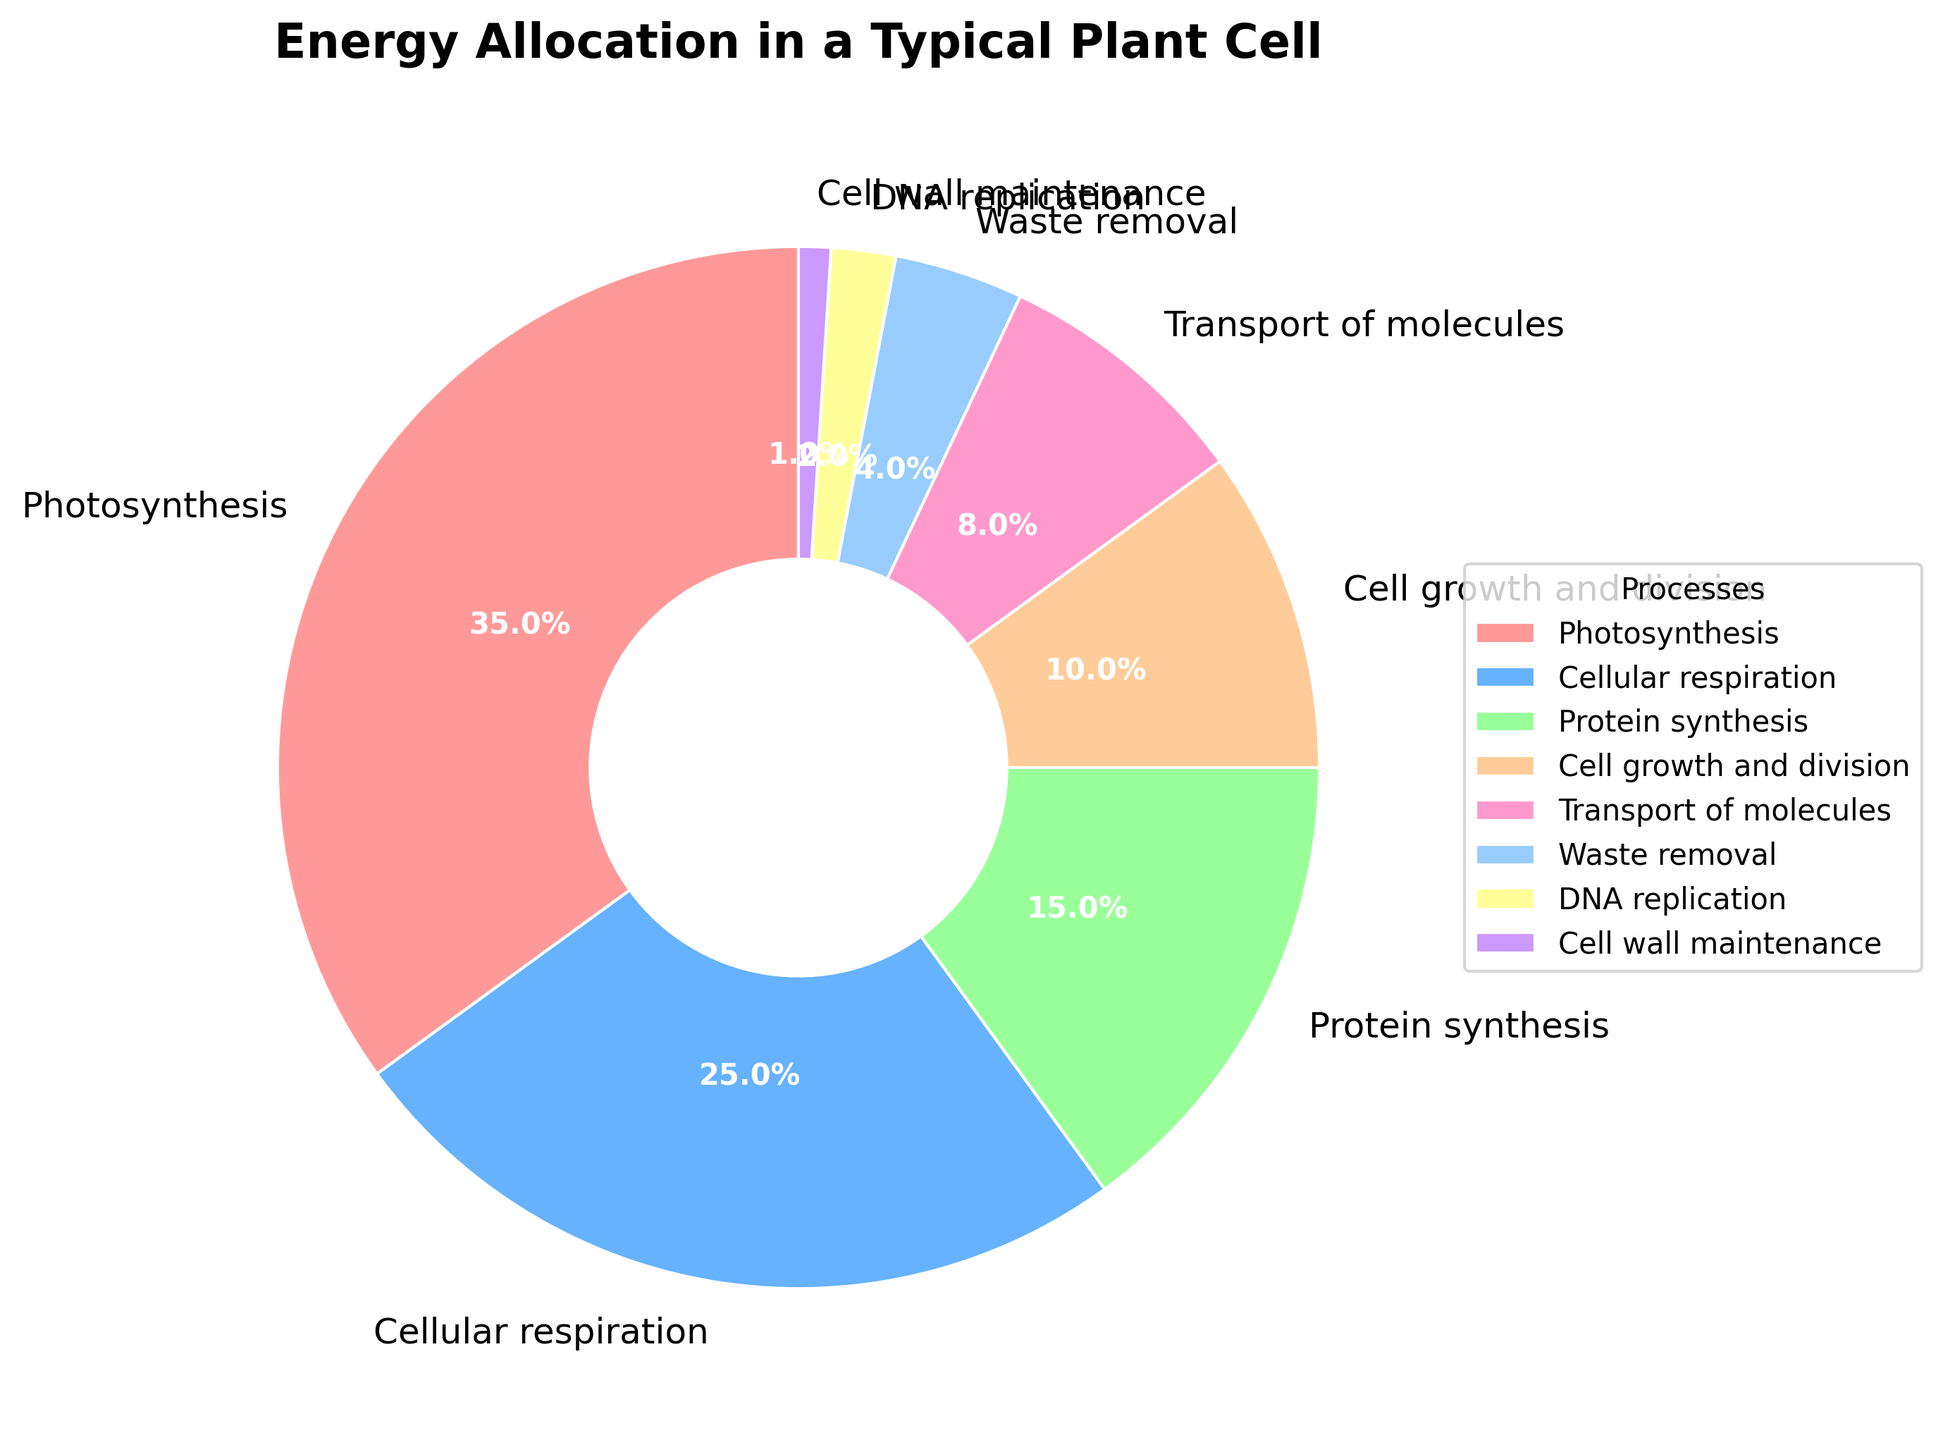What's the largest percentage allocated to any single process? The largest percentage is the one with the maximum value among the given percentages. By examining the chart, Photosynthesis has the largest slice with 35%.
Answer: 35% Which two processes have the smallest allocation combined? The two processes with the smallest allocations are DNA replication and Cell wall maintenance, with 2% and 1% respectively. Adding these two percentages gives: 2% + 1% = 3%.
Answer: 3% Is the energy allocated to Photosynthesis greater than the combined energy for Transport of molecules and Waste removal? Photosynthesis has a percentage of 35%. Transport of molecules and Waste removal have 8% and 4%, respectively. Adding these gives 8% + 4% = 12%. Since 35% > 12%, Photosynthesis has a greater allocation.
Answer: Yes What's the difference in percentage allocation between Cellular respiration and Cell growth and division? Cellular respiration is allocated 25%, while Cell growth and division has 10%. Subtracting these gives: 25% - 10% = 15%.
Answer: 15% Which process is allocated more energy: Protein synthesis or Transport of molecules? Protein synthesis has an allocation of 15%, whereas Transport of molecules has 8%. Since 15% > 8%, Protein synthesis is allocated more energy.
Answer: Protein synthesis If we group Photosynthesis, Cellular respiration, and Protein synthesis together, what’s their combined allocation percentage? The percentages are 35%, 25%, and 15% respectively for Photosynthesis, Cellular respiration, and Protein synthesis. Adding these gives: 35% + 25% + 15% = 75%.
Answer: 75% Does the combined percentage of Cell growth and division and DNA replication exceed the percentage for Protein synthesis? Cell growth and division has 10% and DNA replication has 2%. Adding these gives: 10% + 2% = 12%. Protein synthesis has 15%, which is greater than 12%. So, it does not exceed.
Answer: No How many processes have allocations greater than 10%? By examining the chart, Photosynthesis (35%), Cellular respiration (25%), and Protein synthesis (15%) have allocations greater than 10%. That makes a total of 3 processes.
Answer: 3 What's the combined percentage of all processes excluding Photosynthesis? Excluding Photosynthesis (35%), we sum the remaining percentages: 25% (Cellular respiration) + 15% (Protein synthesis) + 10% (Cell growth and division) + 8% (Transport of molecules) + 4% (Waste removal) + 2% (DNA replication) + 1% (Cell wall maintenance). This gives: 25% + 15% + 10% + 8% + 4% + 2% + 1% = 65%.
Answer: 65% 